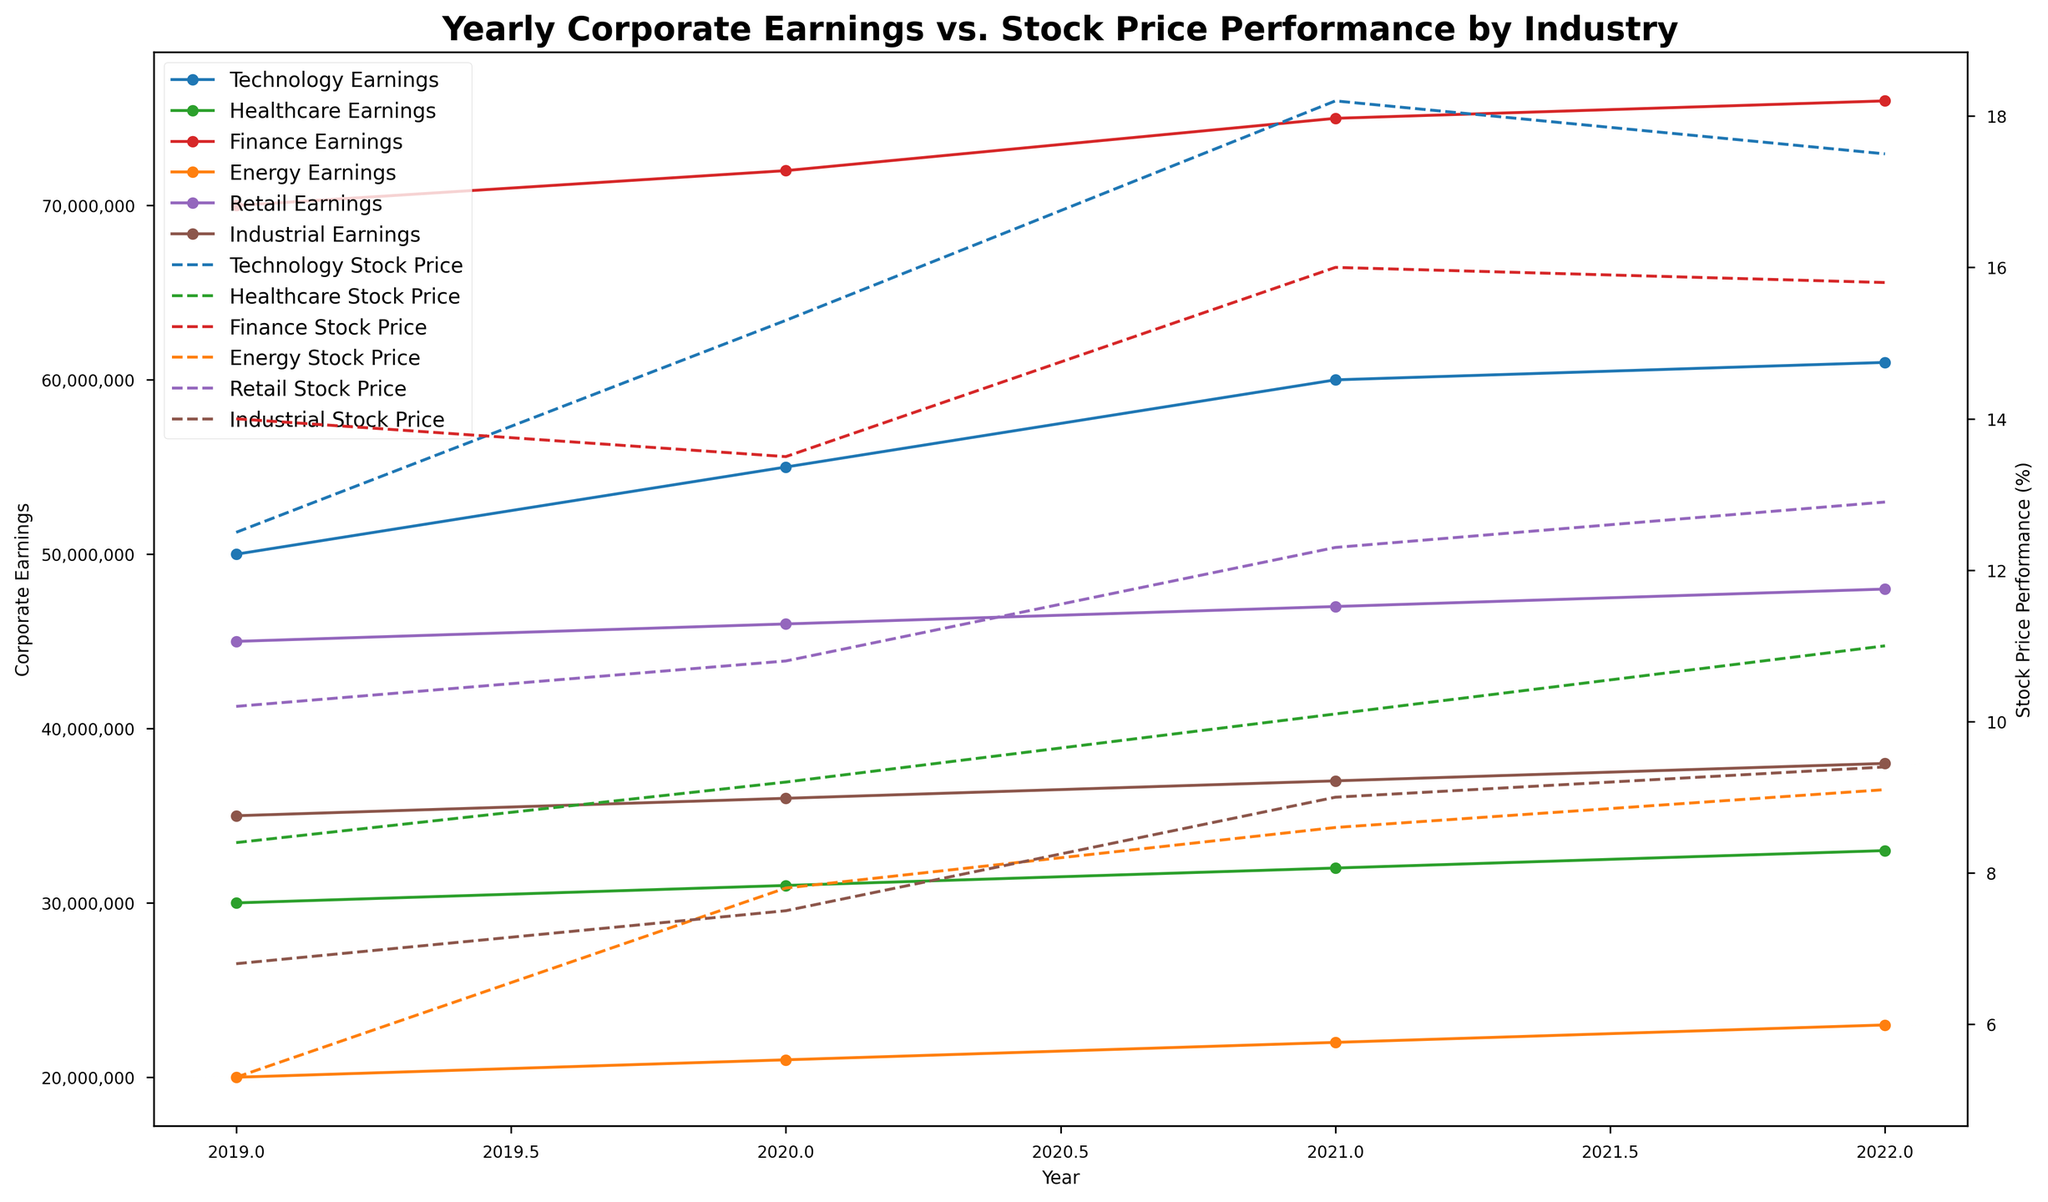Which industry showed the highest corporate earnings in 2022? Look at the 2022 data points for Corporate Earnings on the primary (left) y-axis and identify the highest value and its corresponding industry.
Answer: Finance Which industry's stock price performance increased the most from 2019 to 2022? Compare the stock price performance percentage from 2019 to 2022 for each industry using the secondary (right) y-axis. Calculate the difference for each and find the maximum.
Answer: Healthcare What is the average yearly corporate earnings for the Technology sector from 2019 to 2022? Sum the corporate earnings for the Technology sector from 2019 to 2022 and then divide by the number of years (4).
Answer: 56,250,000 Between 2020 and 2021, which industry had the highest percentage increase in stock price performance? For each industry, calculate the percentage increase in stock price from 2020 to 2021 using the formula: ((2021 value - 2020 value) / 2020 value) * 100%. Identify the highest percentage increase.
Answer: Energy How does the stock price performance of the Energy sector in 2022 compare to the Retail sector in 2022? Look at the stock price performance for both Energy and Retail sectors in 2022 on the secondary (right) y-axis and compare the values.
Answer: Energy is lower than Retail Calculate the total corporate earnings in 2021 for all industries combined. Sum the corporate earnings for all industries in 2021 by looking at the primary (left) y-axis values for that year.
Answer: 339,000,000 Which sector had the least stock price performance change from 2021 to 2022? Calculate the stock price performance change for each sector from 2021 to 2022 and identify the smallest change by comparing the values.
Answer: Finance What is the general trend in the Healthcare sector's corporate earnings from 2019 to 2022? Observe the corporate earnings values for the Healthcare sector from 2019 to 2022 on the primary (left) y-axis and describe the trend.
Answer: Increasing trend Compare corporate earnings between the Technology and Finance sectors in 2020. Which sector earned more? Look at the corporate earnings for both Technology and Finance sectors in 2020 on the primary (left) y-axis and compare the values.
Answer: Finance What is the difference in stock price performance between Industrial and Energy sectors in 2021? Find the stock price performance for both Industrial and Energy sectors in 2021 on the secondary (right) y-axis and subtract the smaller value from the larger value.
Answer: 0.4 